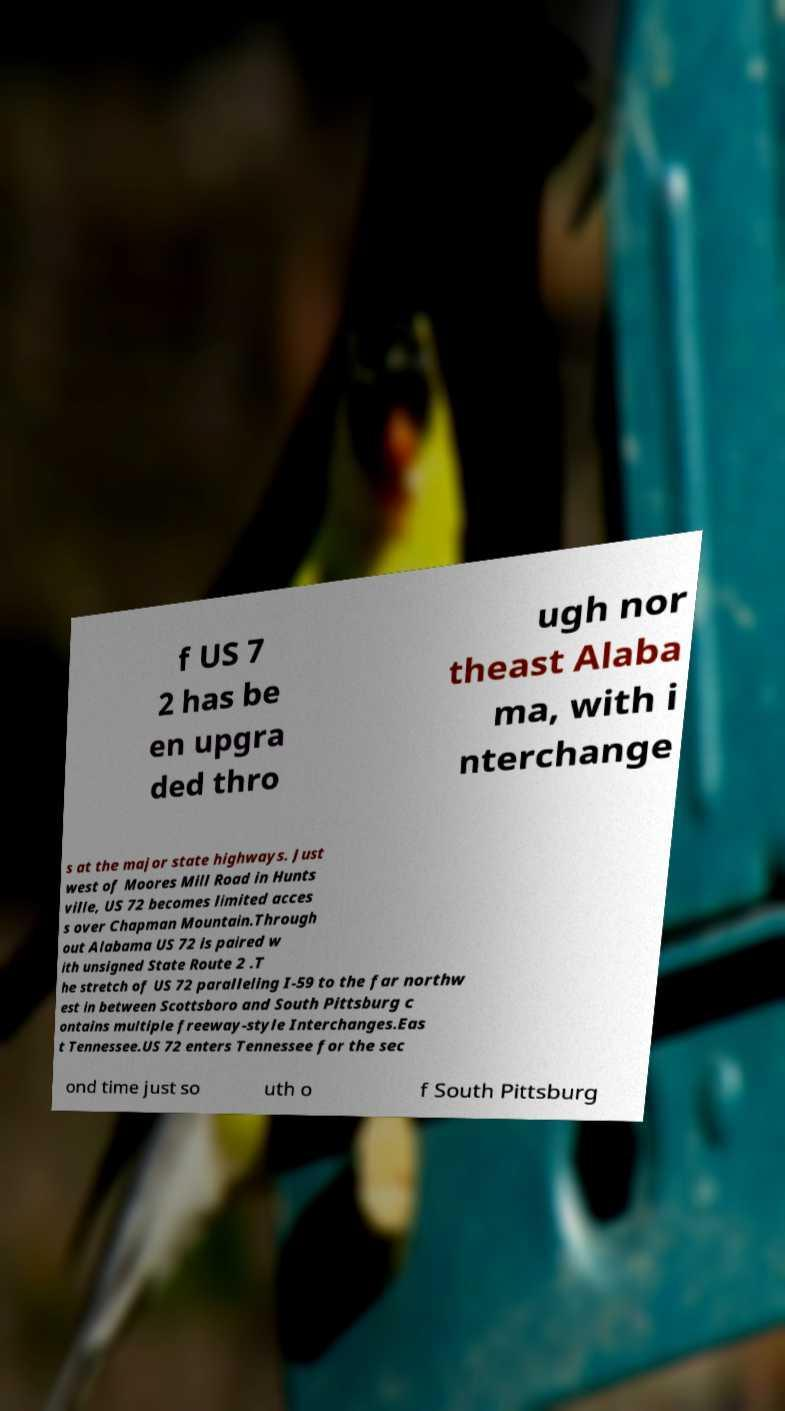Please identify and transcribe the text found in this image. f US 7 2 has be en upgra ded thro ugh nor theast Alaba ma, with i nterchange s at the major state highways. Just west of Moores Mill Road in Hunts ville, US 72 becomes limited acces s over Chapman Mountain.Through out Alabama US 72 is paired w ith unsigned State Route 2 .T he stretch of US 72 paralleling I-59 to the far northw est in between Scottsboro and South Pittsburg c ontains multiple freeway-style Interchanges.Eas t Tennessee.US 72 enters Tennessee for the sec ond time just so uth o f South Pittsburg 